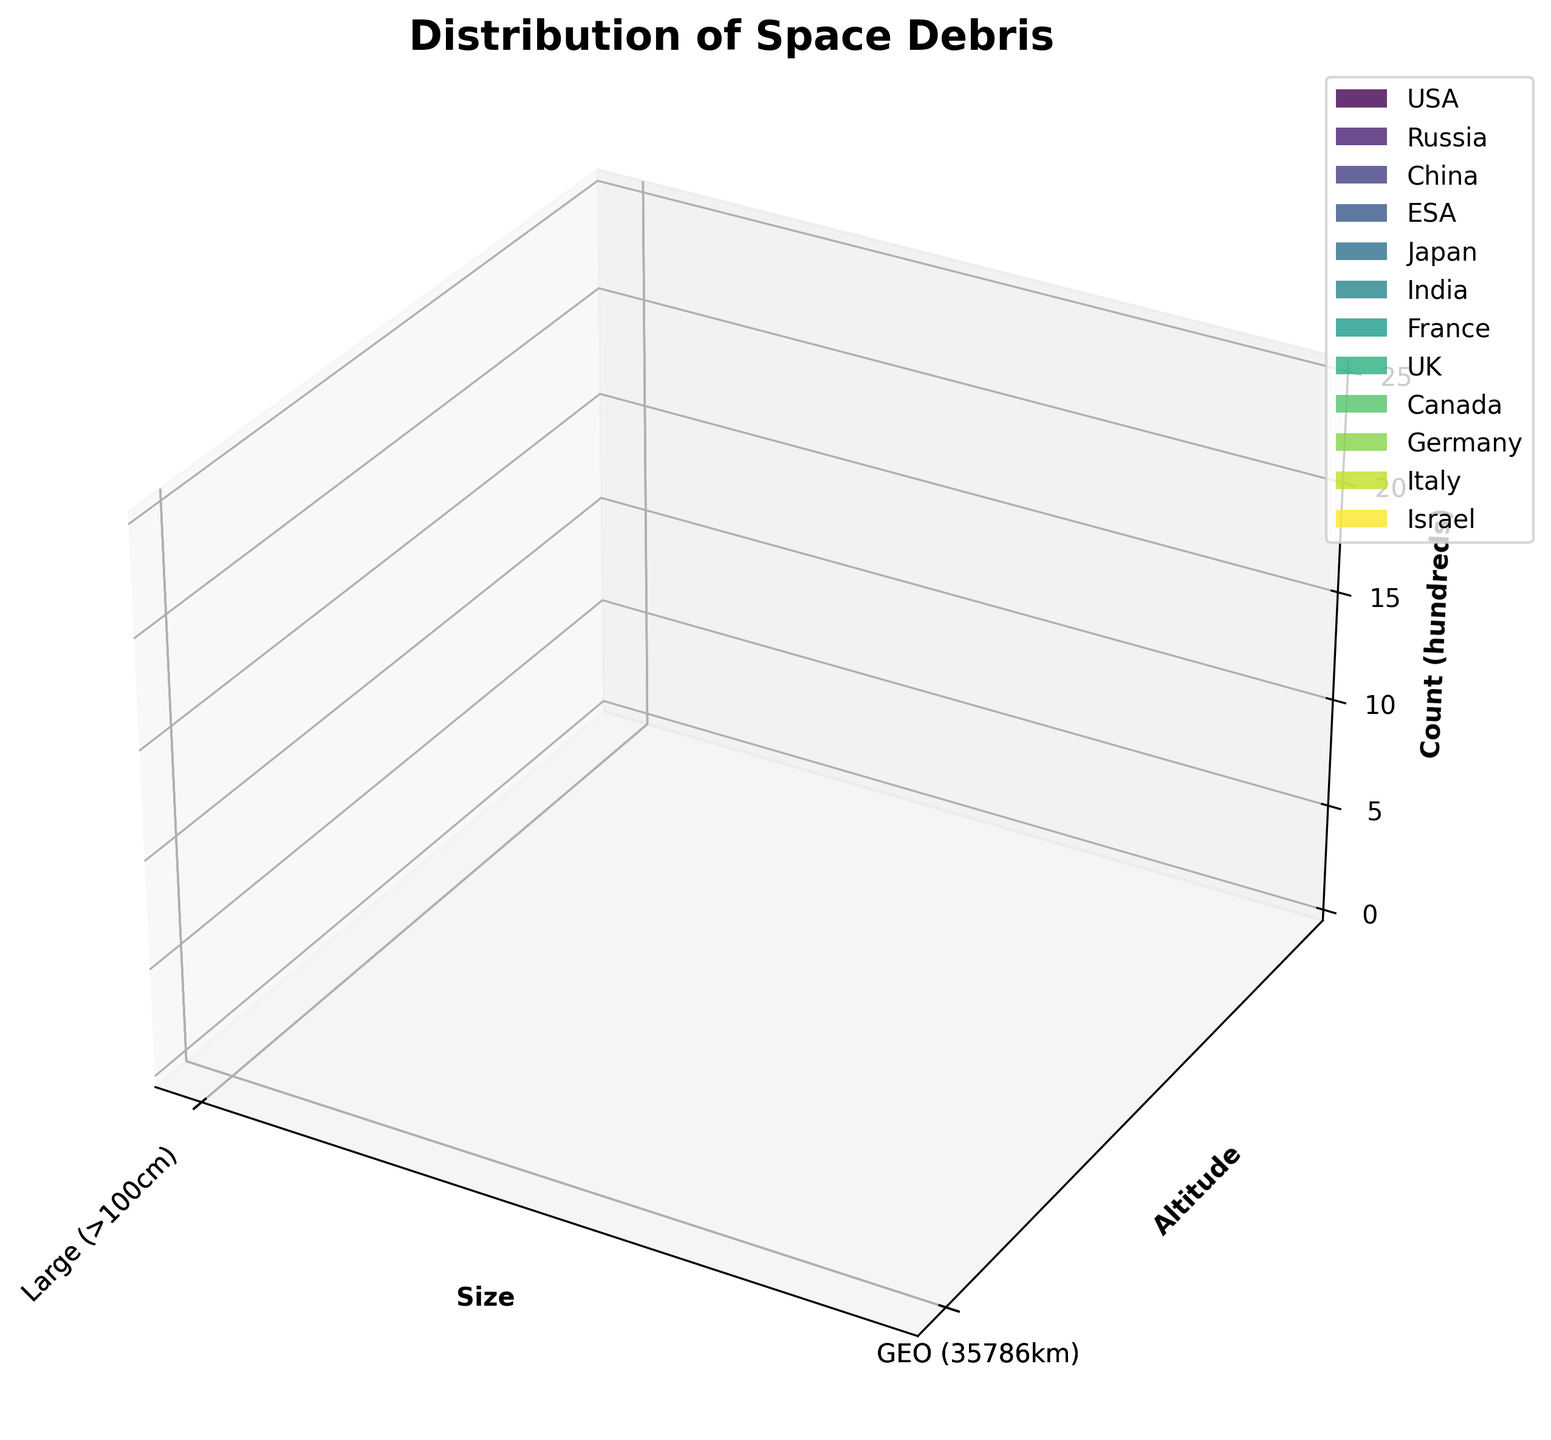what is the title of the figure? By looking at the top section of the plot, we can see the title displayed. The title is a summary of what the plot is about.
Answer: Distribution of Space Debris What is on the x-axis of the plot? The x-axis typically represents one of the variables in the dataset, which we can observe at its base. In this case, the x-axis represents different sizes of space debris.
Answer: Size How many countries contribute to the space debris in the plot? The legend on the right-hand side of the figure contains the list of all countries denoted by different colors. We can count the number of entries in this legend.
Answer: 10 Which country has the highest count of small debris in LEO? By observing the bars corresponding to the 'Small (<10cm)' size and 'LEO (400-1000km)' altitude, and checking for the tallest bar within this category while referring to the legend for the corresponding country.
Answer: USA Between USA and ESA, which has more medium size debris in MEO? We need to compare the heights of the bars representing the 'Medium (10-100cm)' debris at 'MEO (1000-35786km)' altitude for both USA and ESA by looking at the color and size. However, we notice ESA is not in that category on the plot.
Answer: USA What is the total count of large debris in GEO from all countries combined? To find this, we need to look at all the bars corresponding to 'Large (>100cm)' size and 'GEO (35786km)' altitude. We sum the heights represented by these bars for all countries. Approximately: China (800) + India (400) + Canada (300) + Israel (200)=1700
Answer: 1700 Which country has the lowest count of large debris in GEO? Focusing on the 'Large (>100cm)' category within 'GEO (35786km)' altitude, we compare the heights of the bars from each country and identify the lowest one by cross-referencing with the legend.
Answer: Israel What is the overall altitude range depicted on the y-axis? By looking at the labels on the y-axis, we can see the range of altitudes covered in the plot, represented by the three altitude categories along the y-axis.
Answer: 400 to 35786km Which altitude category has the most space debris from the UK? Reviewing the bars corresponding to different altitude categories while identifying the color associated with the UK, we check the heights of these bars. We note the respective count for each altitude to determine the highest value.
Answer: MEO How does the space debris from Japan compare among size categories within MEO? Identifying the bars for Japan color-coded by observing each size category within the 'MEO (1000-35786km)' altitude and comparing the heights of these bars to understand the distribution among these sizes.
Answer: Medium size has the most debris 